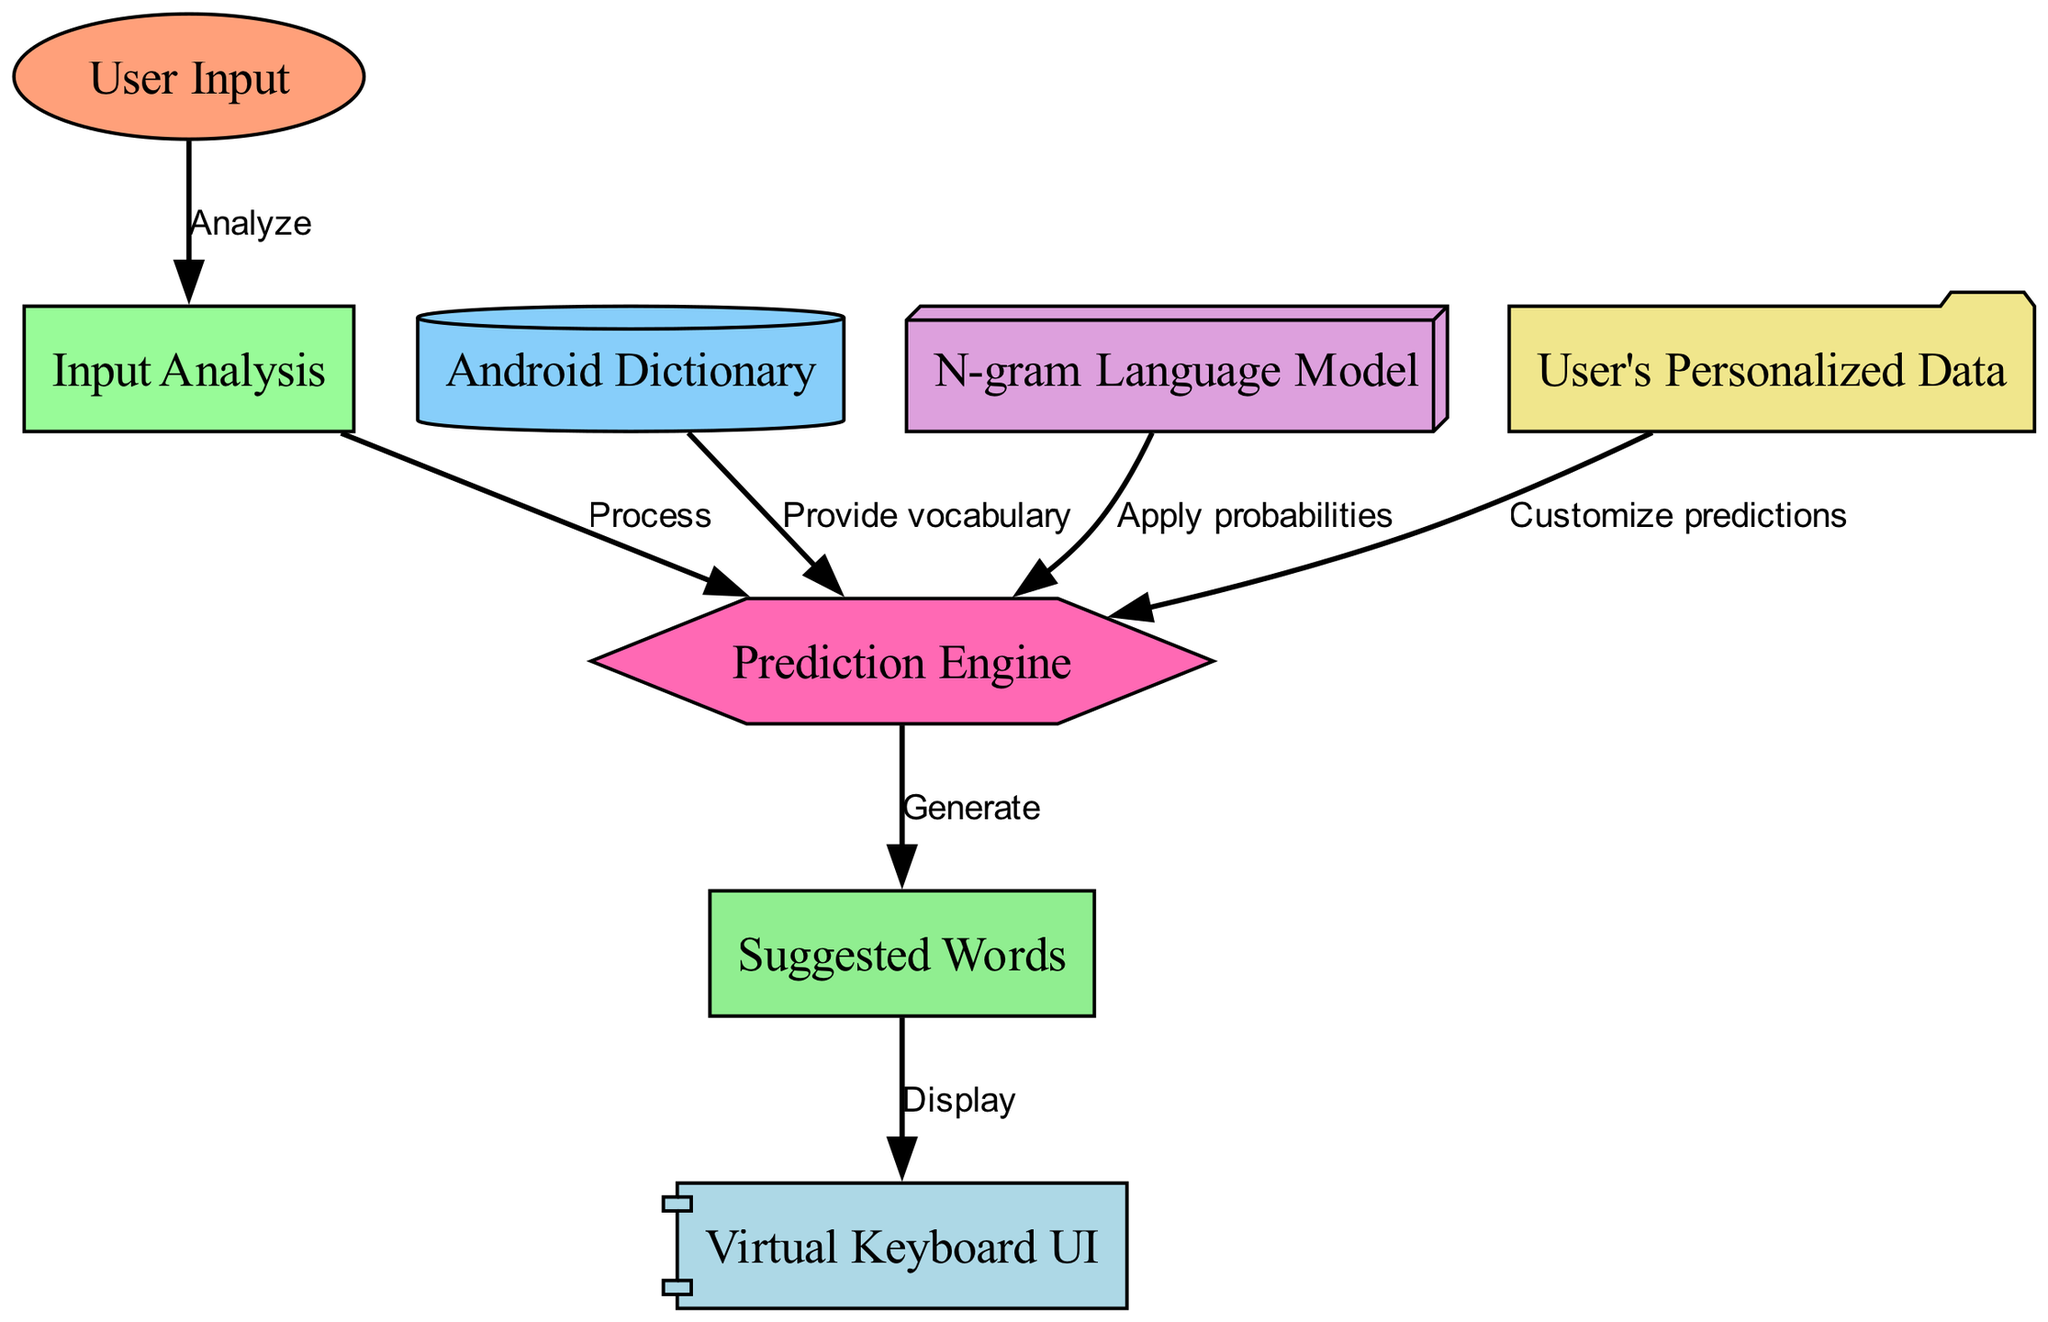What is the first step in the predictive text data flow? The diagram indicates that the first step is user input, as it is the starting node that leads to input analysis.
Answer: User Input How many nodes are present in the diagram? Counting each of the distinct labels or nodes, we find there are eight nodes in total.
Answer: 8 What is the output of the prediction engine? The prediction engine generates suggestions based on the processed input data. This is explicitly stated as output flowing from the prediction engine to the suggestions node.
Answer: Suggested Words Which component provides vocabulary to the prediction engine? The dictionary node supplies vocabulary to the prediction engine, as indicated by the connecting edge labeled "Provide vocabulary."
Answer: Android Dictionary What is the relationship between input analysis and the prediction engine? The edge connecting input analysis to the prediction engine is labeled "Process," indicating that input analysis is necessary for the prediction engine to function.
Answer: Process What node is responsible for customizing predictions? The node responsible for customizing predictions is the user's personalized data, which directly influences the prediction engine's outputs.
Answer: User's Personalized Data Which two components influence the prediction engine's functioning? The prediction engine's functioning is influenced by the dictionary and the language model, as both are connected to it and labeled with their respective provisions.
Answer: Android Dictionary and N-gram Language Model What is displayed in the virtual keyboard UI? The virtual keyboard UI displays the suggestions generated by the prediction engine, as shown in the flow from suggestions to keyboard UI.
Answer: Suggested Words 